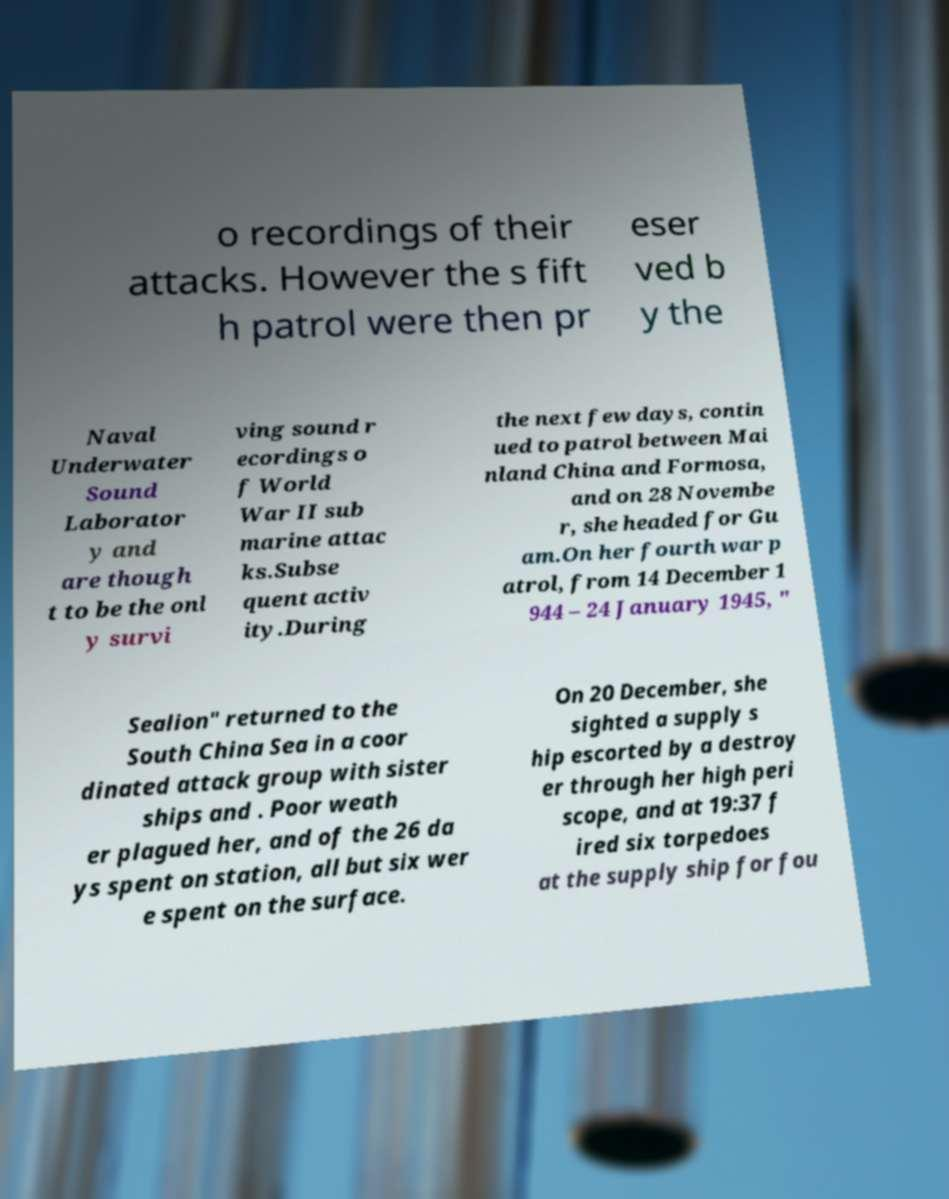Please identify and transcribe the text found in this image. o recordings of their attacks. However the s fift h patrol were then pr eser ved b y the Naval Underwater Sound Laborator y and are though t to be the onl y survi ving sound r ecordings o f World War II sub marine attac ks.Subse quent activ ity.During the next few days, contin ued to patrol between Mai nland China and Formosa, and on 28 Novembe r, she headed for Gu am.On her fourth war p atrol, from 14 December 1 944 – 24 January 1945, " Sealion" returned to the South China Sea in a coor dinated attack group with sister ships and . Poor weath er plagued her, and of the 26 da ys spent on station, all but six wer e spent on the surface. On 20 December, she sighted a supply s hip escorted by a destroy er through her high peri scope, and at 19:37 f ired six torpedoes at the supply ship for fou 